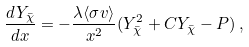<formula> <loc_0><loc_0><loc_500><loc_500>\frac { d Y _ { \bar { \chi } } } { d x } = - \frac { \lambda \langle \sigma v \rangle } { x ^ { 2 } } ( Y _ { \bar { \chi } } ^ { 2 } + C Y _ { \bar { \chi } } - P ) \, ,</formula> 